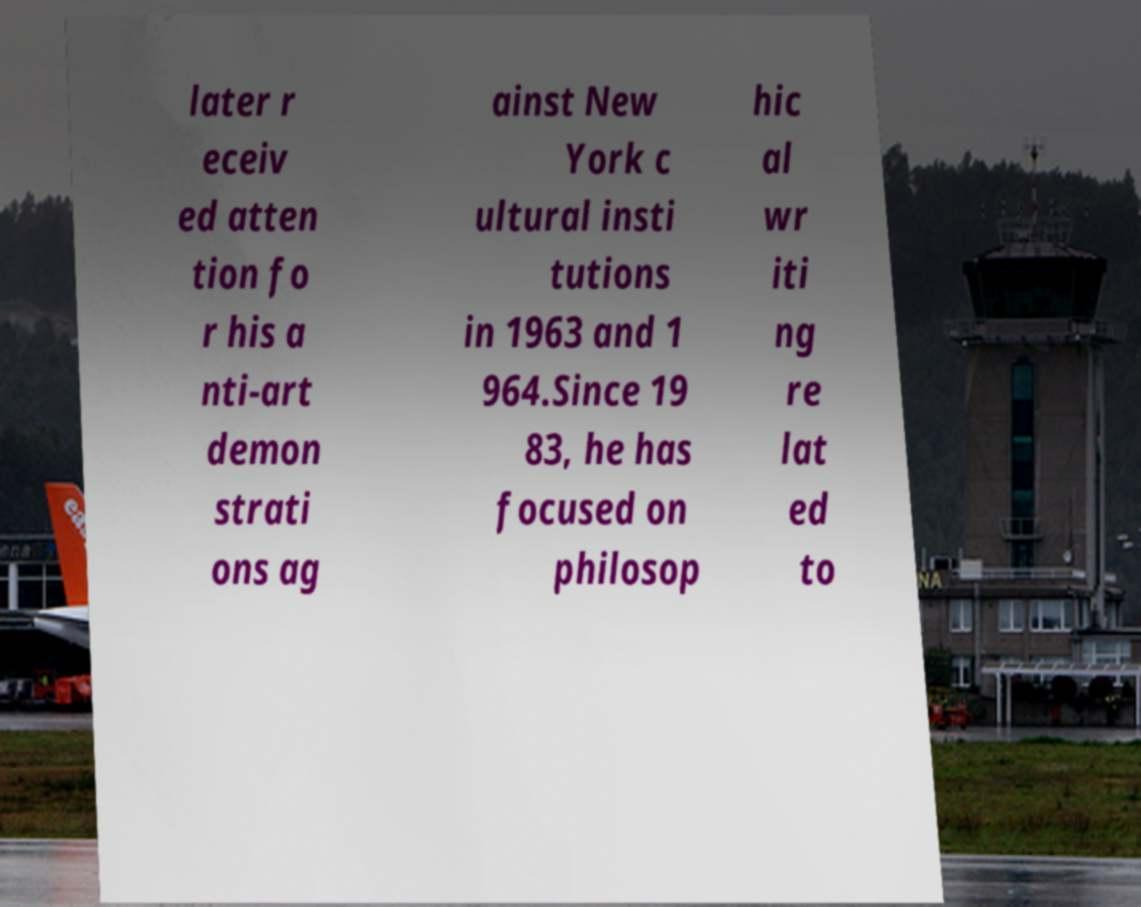Could you extract and type out the text from this image? later r eceiv ed atten tion fo r his a nti-art demon strati ons ag ainst New York c ultural insti tutions in 1963 and 1 964.Since 19 83, he has focused on philosop hic al wr iti ng re lat ed to 